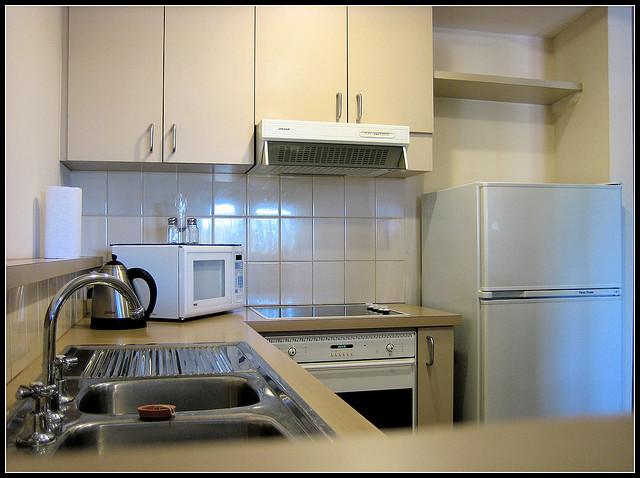Is this kitchen out of paper towels?
Short answer required. No. How many handles are visible?
Answer briefly. 5. Where is the fridge?
Write a very short answer. On right. 